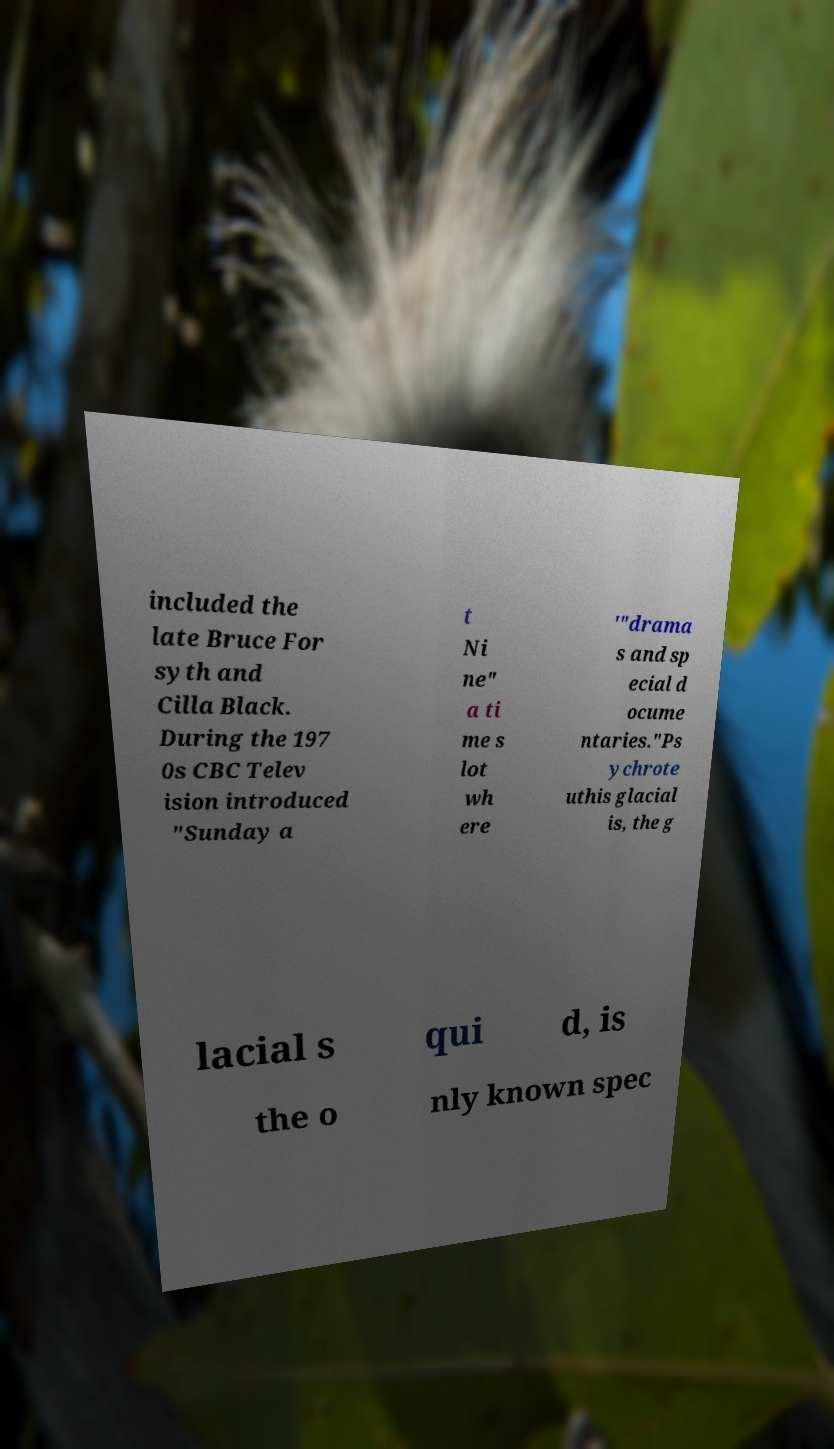I need the written content from this picture converted into text. Can you do that? included the late Bruce For syth and Cilla Black. During the 197 0s CBC Telev ision introduced "Sunday a t Ni ne" a ti me s lot wh ere '"drama s and sp ecial d ocume ntaries."Ps ychrote uthis glacial is, the g lacial s qui d, is the o nly known spec 